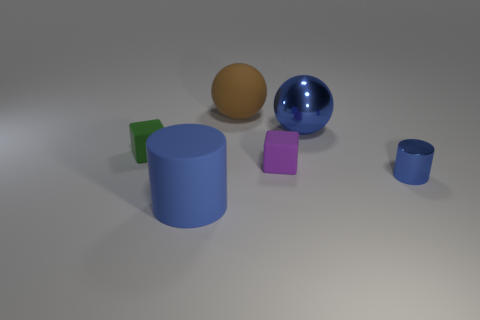Add 2 blocks. How many objects exist? 8 Subtract all big rubber things. Subtract all rubber balls. How many objects are left? 3 Add 3 purple matte things. How many purple matte things are left? 4 Add 2 large green objects. How many large green objects exist? 2 Subtract 0 gray cylinders. How many objects are left? 6 